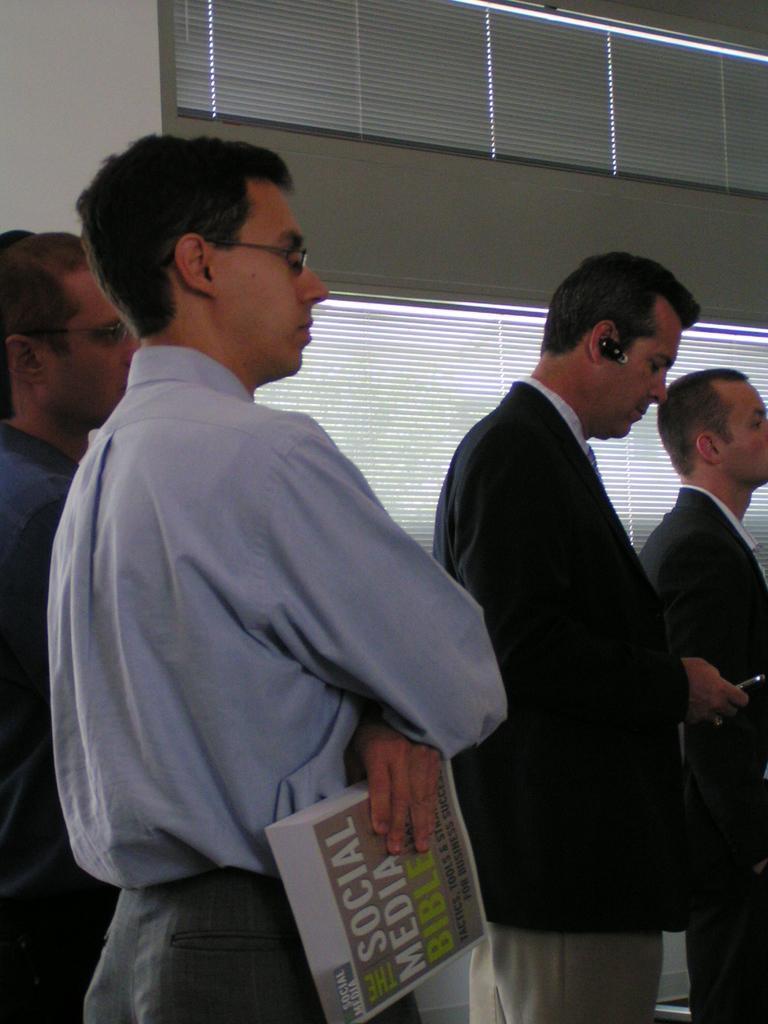In one or two sentences, can you explain what this image depicts? In this picture there are group of people standing and there is a person standing and holding the book and there is a person standing and holding the device. At the back there are window blinds and there is a wall. 